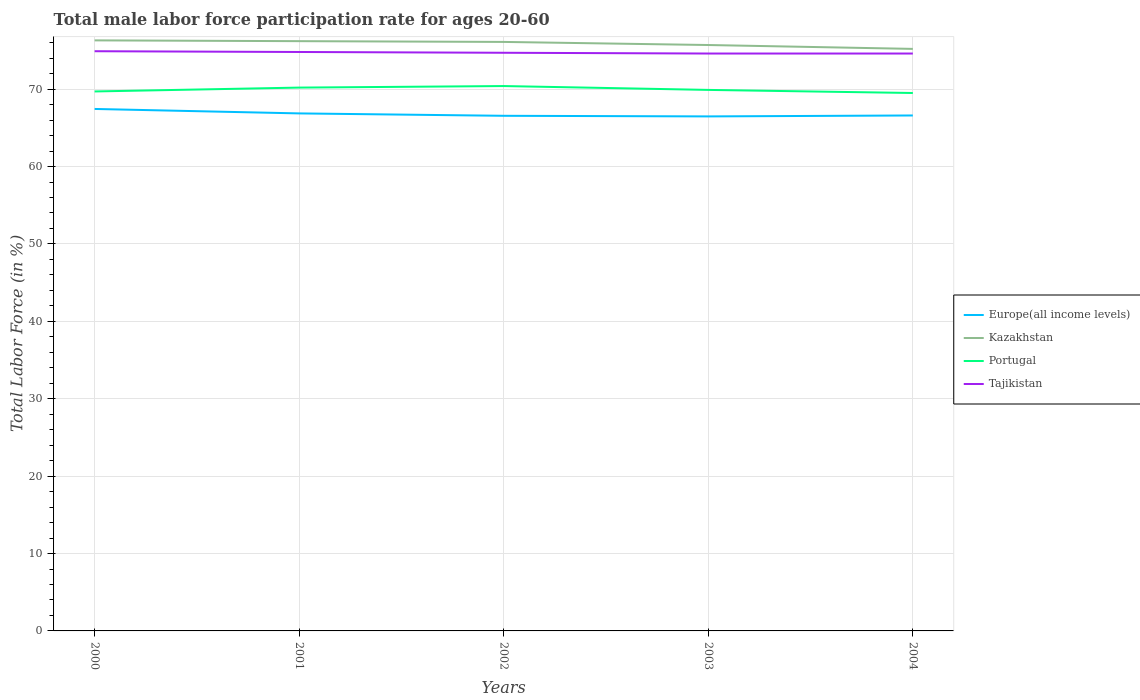Across all years, what is the maximum male labor force participation rate in Europe(all income levels)?
Your response must be concise. 66.48. In which year was the male labor force participation rate in Portugal maximum?
Your response must be concise. 2004. What is the total male labor force participation rate in Europe(all income levels) in the graph?
Offer a very short reply. 0.39. What is the difference between the highest and the second highest male labor force participation rate in Portugal?
Provide a succinct answer. 0.9. Does the graph contain any zero values?
Your answer should be compact. No. Does the graph contain grids?
Your answer should be very brief. Yes. How many legend labels are there?
Provide a succinct answer. 4. What is the title of the graph?
Your answer should be compact. Total male labor force participation rate for ages 20-60. What is the label or title of the X-axis?
Make the answer very short. Years. What is the Total Labor Force (in %) of Europe(all income levels) in 2000?
Provide a short and direct response. 67.44. What is the Total Labor Force (in %) of Kazakhstan in 2000?
Give a very brief answer. 76.3. What is the Total Labor Force (in %) in Portugal in 2000?
Give a very brief answer. 69.7. What is the Total Labor Force (in %) of Tajikistan in 2000?
Your response must be concise. 74.9. What is the Total Labor Force (in %) of Europe(all income levels) in 2001?
Keep it short and to the point. 66.86. What is the Total Labor Force (in %) of Kazakhstan in 2001?
Make the answer very short. 76.2. What is the Total Labor Force (in %) in Portugal in 2001?
Keep it short and to the point. 70.2. What is the Total Labor Force (in %) of Tajikistan in 2001?
Give a very brief answer. 74.8. What is the Total Labor Force (in %) in Europe(all income levels) in 2002?
Give a very brief answer. 66.56. What is the Total Labor Force (in %) in Kazakhstan in 2002?
Provide a short and direct response. 76.1. What is the Total Labor Force (in %) in Portugal in 2002?
Offer a very short reply. 70.4. What is the Total Labor Force (in %) in Tajikistan in 2002?
Your response must be concise. 74.7. What is the Total Labor Force (in %) of Europe(all income levels) in 2003?
Offer a terse response. 66.48. What is the Total Labor Force (in %) in Kazakhstan in 2003?
Your answer should be very brief. 75.7. What is the Total Labor Force (in %) in Portugal in 2003?
Give a very brief answer. 69.9. What is the Total Labor Force (in %) of Tajikistan in 2003?
Give a very brief answer. 74.6. What is the Total Labor Force (in %) of Europe(all income levels) in 2004?
Offer a very short reply. 66.6. What is the Total Labor Force (in %) of Kazakhstan in 2004?
Your response must be concise. 75.2. What is the Total Labor Force (in %) in Portugal in 2004?
Provide a short and direct response. 69.5. What is the Total Labor Force (in %) in Tajikistan in 2004?
Offer a very short reply. 74.6. Across all years, what is the maximum Total Labor Force (in %) in Europe(all income levels)?
Your answer should be very brief. 67.44. Across all years, what is the maximum Total Labor Force (in %) of Kazakhstan?
Provide a short and direct response. 76.3. Across all years, what is the maximum Total Labor Force (in %) of Portugal?
Offer a terse response. 70.4. Across all years, what is the maximum Total Labor Force (in %) in Tajikistan?
Your answer should be compact. 74.9. Across all years, what is the minimum Total Labor Force (in %) in Europe(all income levels)?
Offer a very short reply. 66.48. Across all years, what is the minimum Total Labor Force (in %) of Kazakhstan?
Provide a short and direct response. 75.2. Across all years, what is the minimum Total Labor Force (in %) of Portugal?
Make the answer very short. 69.5. Across all years, what is the minimum Total Labor Force (in %) of Tajikistan?
Make the answer very short. 74.6. What is the total Total Labor Force (in %) in Europe(all income levels) in the graph?
Ensure brevity in your answer.  333.93. What is the total Total Labor Force (in %) of Kazakhstan in the graph?
Ensure brevity in your answer.  379.5. What is the total Total Labor Force (in %) of Portugal in the graph?
Your response must be concise. 349.7. What is the total Total Labor Force (in %) in Tajikistan in the graph?
Offer a terse response. 373.6. What is the difference between the Total Labor Force (in %) in Europe(all income levels) in 2000 and that in 2001?
Offer a terse response. 0.58. What is the difference between the Total Labor Force (in %) of Portugal in 2000 and that in 2001?
Ensure brevity in your answer.  -0.5. What is the difference between the Total Labor Force (in %) of Tajikistan in 2000 and that in 2001?
Keep it short and to the point. 0.1. What is the difference between the Total Labor Force (in %) in Europe(all income levels) in 2000 and that in 2002?
Provide a short and direct response. 0.88. What is the difference between the Total Labor Force (in %) of Europe(all income levels) in 2000 and that in 2003?
Give a very brief answer. 0.96. What is the difference between the Total Labor Force (in %) of Portugal in 2000 and that in 2003?
Offer a terse response. -0.2. What is the difference between the Total Labor Force (in %) in Tajikistan in 2000 and that in 2003?
Offer a very short reply. 0.3. What is the difference between the Total Labor Force (in %) of Europe(all income levels) in 2000 and that in 2004?
Make the answer very short. 0.84. What is the difference between the Total Labor Force (in %) in Portugal in 2000 and that in 2004?
Offer a very short reply. 0.2. What is the difference between the Total Labor Force (in %) of Europe(all income levels) in 2001 and that in 2002?
Offer a terse response. 0.31. What is the difference between the Total Labor Force (in %) in Kazakhstan in 2001 and that in 2002?
Keep it short and to the point. 0.1. What is the difference between the Total Labor Force (in %) in Portugal in 2001 and that in 2002?
Make the answer very short. -0.2. What is the difference between the Total Labor Force (in %) of Tajikistan in 2001 and that in 2002?
Provide a short and direct response. 0.1. What is the difference between the Total Labor Force (in %) in Europe(all income levels) in 2001 and that in 2003?
Your answer should be very brief. 0.39. What is the difference between the Total Labor Force (in %) in Tajikistan in 2001 and that in 2003?
Your response must be concise. 0.2. What is the difference between the Total Labor Force (in %) in Europe(all income levels) in 2001 and that in 2004?
Provide a succinct answer. 0.27. What is the difference between the Total Labor Force (in %) in Kazakhstan in 2001 and that in 2004?
Make the answer very short. 1. What is the difference between the Total Labor Force (in %) in Europe(all income levels) in 2002 and that in 2003?
Your answer should be very brief. 0.08. What is the difference between the Total Labor Force (in %) of Tajikistan in 2002 and that in 2003?
Provide a short and direct response. 0.1. What is the difference between the Total Labor Force (in %) in Europe(all income levels) in 2002 and that in 2004?
Provide a succinct answer. -0.04. What is the difference between the Total Labor Force (in %) in Portugal in 2002 and that in 2004?
Provide a short and direct response. 0.9. What is the difference between the Total Labor Force (in %) in Tajikistan in 2002 and that in 2004?
Ensure brevity in your answer.  0.1. What is the difference between the Total Labor Force (in %) in Europe(all income levels) in 2003 and that in 2004?
Your answer should be very brief. -0.12. What is the difference between the Total Labor Force (in %) in Portugal in 2003 and that in 2004?
Your response must be concise. 0.4. What is the difference between the Total Labor Force (in %) of Europe(all income levels) in 2000 and the Total Labor Force (in %) of Kazakhstan in 2001?
Your answer should be compact. -8.76. What is the difference between the Total Labor Force (in %) of Europe(all income levels) in 2000 and the Total Labor Force (in %) of Portugal in 2001?
Your response must be concise. -2.76. What is the difference between the Total Labor Force (in %) of Europe(all income levels) in 2000 and the Total Labor Force (in %) of Tajikistan in 2001?
Ensure brevity in your answer.  -7.36. What is the difference between the Total Labor Force (in %) in Kazakhstan in 2000 and the Total Labor Force (in %) in Portugal in 2001?
Provide a short and direct response. 6.1. What is the difference between the Total Labor Force (in %) of Europe(all income levels) in 2000 and the Total Labor Force (in %) of Kazakhstan in 2002?
Give a very brief answer. -8.66. What is the difference between the Total Labor Force (in %) of Europe(all income levels) in 2000 and the Total Labor Force (in %) of Portugal in 2002?
Provide a short and direct response. -2.96. What is the difference between the Total Labor Force (in %) of Europe(all income levels) in 2000 and the Total Labor Force (in %) of Tajikistan in 2002?
Your response must be concise. -7.26. What is the difference between the Total Labor Force (in %) in Kazakhstan in 2000 and the Total Labor Force (in %) in Tajikistan in 2002?
Ensure brevity in your answer.  1.6. What is the difference between the Total Labor Force (in %) in Europe(all income levels) in 2000 and the Total Labor Force (in %) in Kazakhstan in 2003?
Make the answer very short. -8.26. What is the difference between the Total Labor Force (in %) of Europe(all income levels) in 2000 and the Total Labor Force (in %) of Portugal in 2003?
Provide a succinct answer. -2.46. What is the difference between the Total Labor Force (in %) in Europe(all income levels) in 2000 and the Total Labor Force (in %) in Tajikistan in 2003?
Provide a short and direct response. -7.16. What is the difference between the Total Labor Force (in %) in Portugal in 2000 and the Total Labor Force (in %) in Tajikistan in 2003?
Make the answer very short. -4.9. What is the difference between the Total Labor Force (in %) of Europe(all income levels) in 2000 and the Total Labor Force (in %) of Kazakhstan in 2004?
Keep it short and to the point. -7.76. What is the difference between the Total Labor Force (in %) of Europe(all income levels) in 2000 and the Total Labor Force (in %) of Portugal in 2004?
Offer a terse response. -2.06. What is the difference between the Total Labor Force (in %) in Europe(all income levels) in 2000 and the Total Labor Force (in %) in Tajikistan in 2004?
Keep it short and to the point. -7.16. What is the difference between the Total Labor Force (in %) in Kazakhstan in 2000 and the Total Labor Force (in %) in Portugal in 2004?
Your answer should be compact. 6.8. What is the difference between the Total Labor Force (in %) of Europe(all income levels) in 2001 and the Total Labor Force (in %) of Kazakhstan in 2002?
Provide a succinct answer. -9.24. What is the difference between the Total Labor Force (in %) of Europe(all income levels) in 2001 and the Total Labor Force (in %) of Portugal in 2002?
Make the answer very short. -3.54. What is the difference between the Total Labor Force (in %) of Europe(all income levels) in 2001 and the Total Labor Force (in %) of Tajikistan in 2002?
Your answer should be very brief. -7.84. What is the difference between the Total Labor Force (in %) in Kazakhstan in 2001 and the Total Labor Force (in %) in Tajikistan in 2002?
Provide a succinct answer. 1.5. What is the difference between the Total Labor Force (in %) of Portugal in 2001 and the Total Labor Force (in %) of Tajikistan in 2002?
Give a very brief answer. -4.5. What is the difference between the Total Labor Force (in %) in Europe(all income levels) in 2001 and the Total Labor Force (in %) in Kazakhstan in 2003?
Your response must be concise. -8.84. What is the difference between the Total Labor Force (in %) of Europe(all income levels) in 2001 and the Total Labor Force (in %) of Portugal in 2003?
Keep it short and to the point. -3.04. What is the difference between the Total Labor Force (in %) of Europe(all income levels) in 2001 and the Total Labor Force (in %) of Tajikistan in 2003?
Ensure brevity in your answer.  -7.74. What is the difference between the Total Labor Force (in %) of Kazakhstan in 2001 and the Total Labor Force (in %) of Tajikistan in 2003?
Your answer should be very brief. 1.6. What is the difference between the Total Labor Force (in %) of Europe(all income levels) in 2001 and the Total Labor Force (in %) of Kazakhstan in 2004?
Ensure brevity in your answer.  -8.34. What is the difference between the Total Labor Force (in %) in Europe(all income levels) in 2001 and the Total Labor Force (in %) in Portugal in 2004?
Your answer should be very brief. -2.64. What is the difference between the Total Labor Force (in %) of Europe(all income levels) in 2001 and the Total Labor Force (in %) of Tajikistan in 2004?
Your response must be concise. -7.74. What is the difference between the Total Labor Force (in %) of Europe(all income levels) in 2002 and the Total Labor Force (in %) of Kazakhstan in 2003?
Your response must be concise. -9.14. What is the difference between the Total Labor Force (in %) in Europe(all income levels) in 2002 and the Total Labor Force (in %) in Portugal in 2003?
Make the answer very short. -3.34. What is the difference between the Total Labor Force (in %) of Europe(all income levels) in 2002 and the Total Labor Force (in %) of Tajikistan in 2003?
Offer a very short reply. -8.04. What is the difference between the Total Labor Force (in %) in Kazakhstan in 2002 and the Total Labor Force (in %) in Portugal in 2003?
Your answer should be compact. 6.2. What is the difference between the Total Labor Force (in %) of Portugal in 2002 and the Total Labor Force (in %) of Tajikistan in 2003?
Provide a succinct answer. -4.2. What is the difference between the Total Labor Force (in %) in Europe(all income levels) in 2002 and the Total Labor Force (in %) in Kazakhstan in 2004?
Make the answer very short. -8.64. What is the difference between the Total Labor Force (in %) of Europe(all income levels) in 2002 and the Total Labor Force (in %) of Portugal in 2004?
Ensure brevity in your answer.  -2.94. What is the difference between the Total Labor Force (in %) of Europe(all income levels) in 2002 and the Total Labor Force (in %) of Tajikistan in 2004?
Keep it short and to the point. -8.04. What is the difference between the Total Labor Force (in %) of Kazakhstan in 2002 and the Total Labor Force (in %) of Portugal in 2004?
Your answer should be very brief. 6.6. What is the difference between the Total Labor Force (in %) of Kazakhstan in 2002 and the Total Labor Force (in %) of Tajikistan in 2004?
Your answer should be compact. 1.5. What is the difference between the Total Labor Force (in %) of Europe(all income levels) in 2003 and the Total Labor Force (in %) of Kazakhstan in 2004?
Offer a terse response. -8.72. What is the difference between the Total Labor Force (in %) in Europe(all income levels) in 2003 and the Total Labor Force (in %) in Portugal in 2004?
Your answer should be compact. -3.02. What is the difference between the Total Labor Force (in %) of Europe(all income levels) in 2003 and the Total Labor Force (in %) of Tajikistan in 2004?
Provide a short and direct response. -8.12. What is the difference between the Total Labor Force (in %) in Kazakhstan in 2003 and the Total Labor Force (in %) in Tajikistan in 2004?
Give a very brief answer. 1.1. What is the difference between the Total Labor Force (in %) of Portugal in 2003 and the Total Labor Force (in %) of Tajikistan in 2004?
Provide a succinct answer. -4.7. What is the average Total Labor Force (in %) of Europe(all income levels) per year?
Offer a very short reply. 66.79. What is the average Total Labor Force (in %) in Kazakhstan per year?
Offer a very short reply. 75.9. What is the average Total Labor Force (in %) of Portugal per year?
Give a very brief answer. 69.94. What is the average Total Labor Force (in %) of Tajikistan per year?
Your answer should be very brief. 74.72. In the year 2000, what is the difference between the Total Labor Force (in %) in Europe(all income levels) and Total Labor Force (in %) in Kazakhstan?
Your answer should be very brief. -8.86. In the year 2000, what is the difference between the Total Labor Force (in %) in Europe(all income levels) and Total Labor Force (in %) in Portugal?
Offer a very short reply. -2.26. In the year 2000, what is the difference between the Total Labor Force (in %) of Europe(all income levels) and Total Labor Force (in %) of Tajikistan?
Your answer should be compact. -7.46. In the year 2001, what is the difference between the Total Labor Force (in %) in Europe(all income levels) and Total Labor Force (in %) in Kazakhstan?
Provide a succinct answer. -9.34. In the year 2001, what is the difference between the Total Labor Force (in %) of Europe(all income levels) and Total Labor Force (in %) of Portugal?
Ensure brevity in your answer.  -3.34. In the year 2001, what is the difference between the Total Labor Force (in %) in Europe(all income levels) and Total Labor Force (in %) in Tajikistan?
Your answer should be compact. -7.94. In the year 2001, what is the difference between the Total Labor Force (in %) of Kazakhstan and Total Labor Force (in %) of Portugal?
Make the answer very short. 6. In the year 2002, what is the difference between the Total Labor Force (in %) of Europe(all income levels) and Total Labor Force (in %) of Kazakhstan?
Keep it short and to the point. -9.54. In the year 2002, what is the difference between the Total Labor Force (in %) in Europe(all income levels) and Total Labor Force (in %) in Portugal?
Make the answer very short. -3.84. In the year 2002, what is the difference between the Total Labor Force (in %) in Europe(all income levels) and Total Labor Force (in %) in Tajikistan?
Ensure brevity in your answer.  -8.14. In the year 2002, what is the difference between the Total Labor Force (in %) in Kazakhstan and Total Labor Force (in %) in Tajikistan?
Provide a short and direct response. 1.4. In the year 2003, what is the difference between the Total Labor Force (in %) in Europe(all income levels) and Total Labor Force (in %) in Kazakhstan?
Keep it short and to the point. -9.22. In the year 2003, what is the difference between the Total Labor Force (in %) of Europe(all income levels) and Total Labor Force (in %) of Portugal?
Your answer should be very brief. -3.42. In the year 2003, what is the difference between the Total Labor Force (in %) in Europe(all income levels) and Total Labor Force (in %) in Tajikistan?
Your answer should be very brief. -8.12. In the year 2003, what is the difference between the Total Labor Force (in %) in Kazakhstan and Total Labor Force (in %) in Tajikistan?
Your answer should be compact. 1.1. In the year 2004, what is the difference between the Total Labor Force (in %) of Europe(all income levels) and Total Labor Force (in %) of Kazakhstan?
Offer a very short reply. -8.6. In the year 2004, what is the difference between the Total Labor Force (in %) of Europe(all income levels) and Total Labor Force (in %) of Portugal?
Provide a short and direct response. -2.9. In the year 2004, what is the difference between the Total Labor Force (in %) in Europe(all income levels) and Total Labor Force (in %) in Tajikistan?
Your answer should be compact. -8. What is the ratio of the Total Labor Force (in %) of Europe(all income levels) in 2000 to that in 2001?
Keep it short and to the point. 1.01. What is the ratio of the Total Labor Force (in %) in Kazakhstan in 2000 to that in 2001?
Your answer should be compact. 1. What is the ratio of the Total Labor Force (in %) of Portugal in 2000 to that in 2001?
Ensure brevity in your answer.  0.99. What is the ratio of the Total Labor Force (in %) of Tajikistan in 2000 to that in 2001?
Keep it short and to the point. 1. What is the ratio of the Total Labor Force (in %) of Europe(all income levels) in 2000 to that in 2002?
Your answer should be very brief. 1.01. What is the ratio of the Total Labor Force (in %) of Tajikistan in 2000 to that in 2002?
Keep it short and to the point. 1. What is the ratio of the Total Labor Force (in %) of Europe(all income levels) in 2000 to that in 2003?
Give a very brief answer. 1.01. What is the ratio of the Total Labor Force (in %) in Kazakhstan in 2000 to that in 2003?
Your answer should be very brief. 1.01. What is the ratio of the Total Labor Force (in %) of Portugal in 2000 to that in 2003?
Your answer should be very brief. 1. What is the ratio of the Total Labor Force (in %) of Europe(all income levels) in 2000 to that in 2004?
Offer a terse response. 1.01. What is the ratio of the Total Labor Force (in %) in Kazakhstan in 2000 to that in 2004?
Give a very brief answer. 1.01. What is the ratio of the Total Labor Force (in %) of Portugal in 2000 to that in 2004?
Provide a succinct answer. 1. What is the ratio of the Total Labor Force (in %) of Europe(all income levels) in 2001 to that in 2002?
Give a very brief answer. 1. What is the ratio of the Total Labor Force (in %) in Kazakhstan in 2001 to that in 2002?
Make the answer very short. 1. What is the ratio of the Total Labor Force (in %) in Tajikistan in 2001 to that in 2002?
Keep it short and to the point. 1. What is the ratio of the Total Labor Force (in %) in Kazakhstan in 2001 to that in 2003?
Your answer should be very brief. 1.01. What is the ratio of the Total Labor Force (in %) of Portugal in 2001 to that in 2003?
Your answer should be very brief. 1. What is the ratio of the Total Labor Force (in %) in Europe(all income levels) in 2001 to that in 2004?
Your response must be concise. 1. What is the ratio of the Total Labor Force (in %) in Kazakhstan in 2001 to that in 2004?
Provide a succinct answer. 1.01. What is the ratio of the Total Labor Force (in %) in Tajikistan in 2001 to that in 2004?
Offer a terse response. 1. What is the ratio of the Total Labor Force (in %) in Europe(all income levels) in 2002 to that in 2003?
Give a very brief answer. 1. What is the ratio of the Total Labor Force (in %) in Kazakhstan in 2002 to that in 2003?
Provide a short and direct response. 1.01. What is the ratio of the Total Labor Force (in %) in Portugal in 2002 to that in 2003?
Your answer should be very brief. 1.01. What is the ratio of the Total Labor Force (in %) of Europe(all income levels) in 2002 to that in 2004?
Offer a very short reply. 1. What is the ratio of the Total Labor Force (in %) of Portugal in 2002 to that in 2004?
Your answer should be very brief. 1.01. What is the ratio of the Total Labor Force (in %) of Tajikistan in 2002 to that in 2004?
Provide a short and direct response. 1. What is the ratio of the Total Labor Force (in %) of Europe(all income levels) in 2003 to that in 2004?
Provide a short and direct response. 1. What is the ratio of the Total Labor Force (in %) in Kazakhstan in 2003 to that in 2004?
Your response must be concise. 1.01. What is the ratio of the Total Labor Force (in %) of Portugal in 2003 to that in 2004?
Make the answer very short. 1.01. What is the difference between the highest and the second highest Total Labor Force (in %) of Europe(all income levels)?
Give a very brief answer. 0.58. What is the difference between the highest and the lowest Total Labor Force (in %) in Europe(all income levels)?
Provide a succinct answer. 0.96. What is the difference between the highest and the lowest Total Labor Force (in %) in Kazakhstan?
Offer a very short reply. 1.1. 